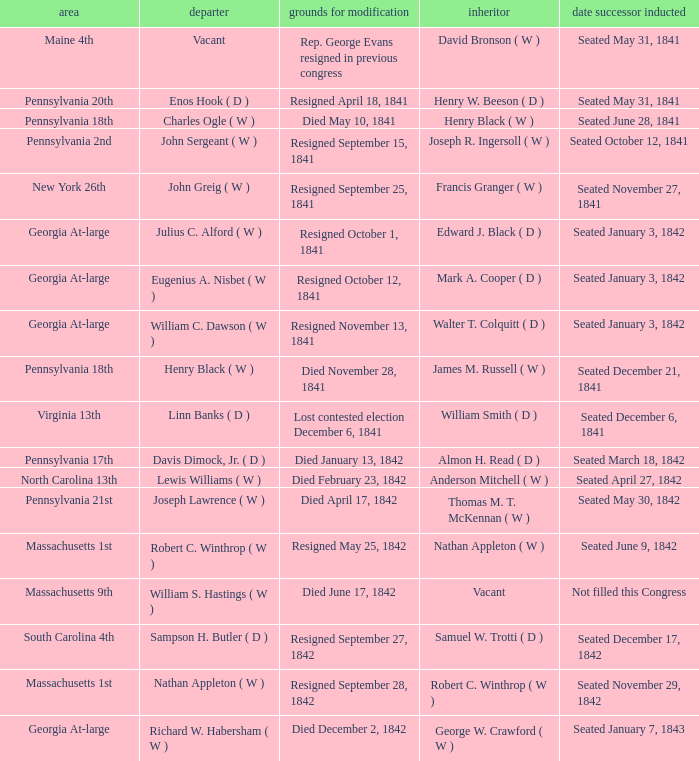Name the successor for north carolina 13th Anderson Mitchell ( W ). 